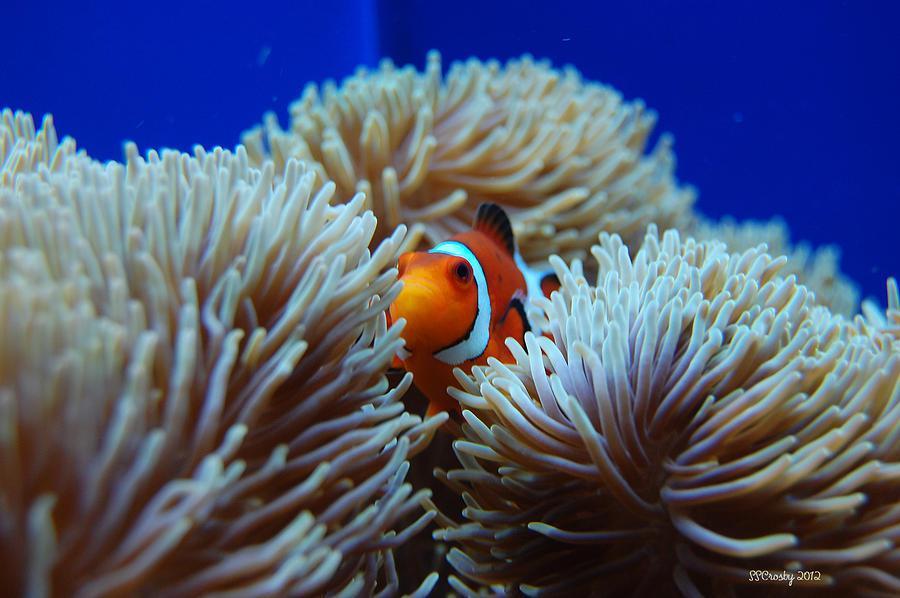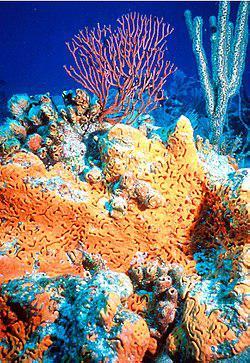The first image is the image on the left, the second image is the image on the right. Examine the images to the left and right. Is the description "An image shows one anemone with ombre-toned reddish-tipped tendrils and a yellow center." accurate? Answer yes or no. No. 